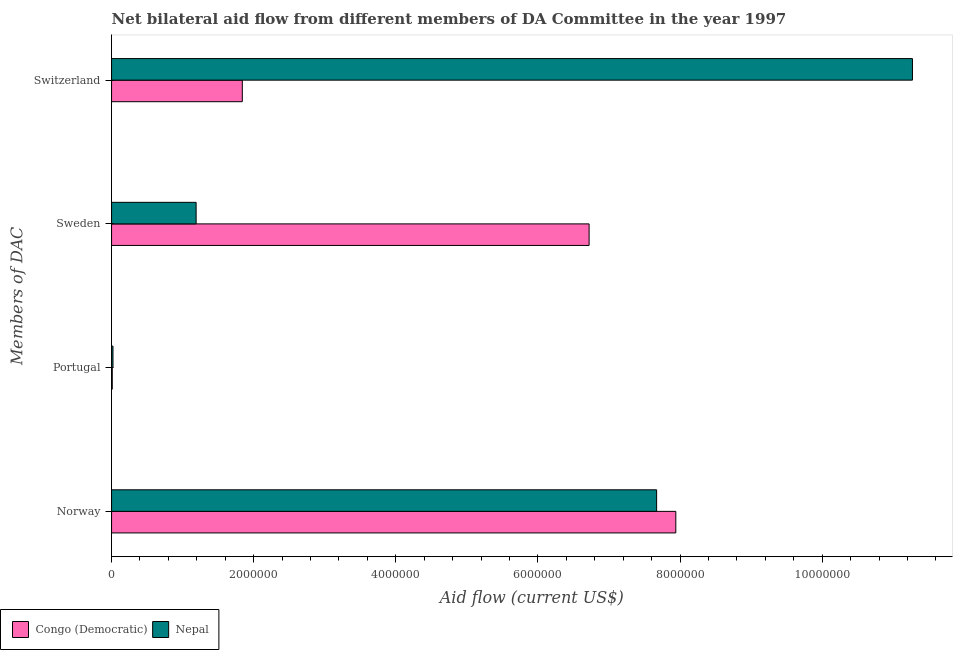How many different coloured bars are there?
Keep it short and to the point. 2. How many groups of bars are there?
Keep it short and to the point. 4. Are the number of bars per tick equal to the number of legend labels?
Offer a terse response. Yes. Are the number of bars on each tick of the Y-axis equal?
Offer a very short reply. Yes. How many bars are there on the 3rd tick from the top?
Provide a short and direct response. 2. How many bars are there on the 1st tick from the bottom?
Your answer should be compact. 2. What is the label of the 3rd group of bars from the top?
Provide a succinct answer. Portugal. What is the amount of aid given by switzerland in Nepal?
Keep it short and to the point. 1.13e+07. Across all countries, what is the maximum amount of aid given by switzerland?
Ensure brevity in your answer.  1.13e+07. Across all countries, what is the minimum amount of aid given by sweden?
Ensure brevity in your answer.  1.19e+06. In which country was the amount of aid given by portugal maximum?
Provide a short and direct response. Nepal. In which country was the amount of aid given by switzerland minimum?
Your response must be concise. Congo (Democratic). What is the total amount of aid given by switzerland in the graph?
Ensure brevity in your answer.  1.31e+07. What is the difference between the amount of aid given by sweden in Nepal and that in Congo (Democratic)?
Keep it short and to the point. -5.53e+06. What is the difference between the amount of aid given by sweden in Congo (Democratic) and the amount of aid given by portugal in Nepal?
Make the answer very short. 6.70e+06. What is the average amount of aid given by norway per country?
Ensure brevity in your answer.  7.80e+06. What is the difference between the amount of aid given by switzerland and amount of aid given by sweden in Congo (Democratic)?
Offer a very short reply. -4.88e+06. In how many countries, is the amount of aid given by sweden greater than 6800000 US$?
Your answer should be very brief. 0. What is the ratio of the amount of aid given by sweden in Congo (Democratic) to that in Nepal?
Your answer should be very brief. 5.65. Is the amount of aid given by sweden in Congo (Democratic) less than that in Nepal?
Make the answer very short. No. What is the difference between the highest and the second highest amount of aid given by sweden?
Ensure brevity in your answer.  5.53e+06. What is the difference between the highest and the lowest amount of aid given by norway?
Your response must be concise. 2.70e+05. In how many countries, is the amount of aid given by portugal greater than the average amount of aid given by portugal taken over all countries?
Your response must be concise. 1. Is the sum of the amount of aid given by sweden in Congo (Democratic) and Nepal greater than the maximum amount of aid given by norway across all countries?
Provide a succinct answer. No. Is it the case that in every country, the sum of the amount of aid given by portugal and amount of aid given by switzerland is greater than the sum of amount of aid given by sweden and amount of aid given by norway?
Your answer should be compact. No. What does the 1st bar from the top in Switzerland represents?
Your answer should be compact. Nepal. What does the 2nd bar from the bottom in Norway represents?
Provide a succinct answer. Nepal. How many bars are there?
Keep it short and to the point. 8. Are all the bars in the graph horizontal?
Offer a very short reply. Yes. How many countries are there in the graph?
Keep it short and to the point. 2. Does the graph contain grids?
Your answer should be compact. No. Where does the legend appear in the graph?
Your response must be concise. Bottom left. How many legend labels are there?
Provide a short and direct response. 2. How are the legend labels stacked?
Keep it short and to the point. Horizontal. What is the title of the graph?
Provide a succinct answer. Net bilateral aid flow from different members of DA Committee in the year 1997. What is the label or title of the Y-axis?
Your answer should be compact. Members of DAC. What is the Aid flow (current US$) in Congo (Democratic) in Norway?
Your answer should be compact. 7.94e+06. What is the Aid flow (current US$) in Nepal in Norway?
Your answer should be compact. 7.67e+06. What is the Aid flow (current US$) of Congo (Democratic) in Portugal?
Your answer should be compact. 10000. What is the Aid flow (current US$) of Congo (Democratic) in Sweden?
Your answer should be very brief. 6.72e+06. What is the Aid flow (current US$) of Nepal in Sweden?
Provide a short and direct response. 1.19e+06. What is the Aid flow (current US$) of Congo (Democratic) in Switzerland?
Give a very brief answer. 1.84e+06. What is the Aid flow (current US$) of Nepal in Switzerland?
Your response must be concise. 1.13e+07. Across all Members of DAC, what is the maximum Aid flow (current US$) of Congo (Democratic)?
Your answer should be very brief. 7.94e+06. Across all Members of DAC, what is the maximum Aid flow (current US$) of Nepal?
Provide a short and direct response. 1.13e+07. Across all Members of DAC, what is the minimum Aid flow (current US$) of Congo (Democratic)?
Ensure brevity in your answer.  10000. Across all Members of DAC, what is the minimum Aid flow (current US$) in Nepal?
Provide a short and direct response. 2.00e+04. What is the total Aid flow (current US$) in Congo (Democratic) in the graph?
Your response must be concise. 1.65e+07. What is the total Aid flow (current US$) in Nepal in the graph?
Keep it short and to the point. 2.02e+07. What is the difference between the Aid flow (current US$) in Congo (Democratic) in Norway and that in Portugal?
Your response must be concise. 7.93e+06. What is the difference between the Aid flow (current US$) in Nepal in Norway and that in Portugal?
Give a very brief answer. 7.65e+06. What is the difference between the Aid flow (current US$) in Congo (Democratic) in Norway and that in Sweden?
Your answer should be very brief. 1.22e+06. What is the difference between the Aid flow (current US$) of Nepal in Norway and that in Sweden?
Make the answer very short. 6.48e+06. What is the difference between the Aid flow (current US$) in Congo (Democratic) in Norway and that in Switzerland?
Offer a very short reply. 6.10e+06. What is the difference between the Aid flow (current US$) of Nepal in Norway and that in Switzerland?
Make the answer very short. -3.60e+06. What is the difference between the Aid flow (current US$) of Congo (Democratic) in Portugal and that in Sweden?
Make the answer very short. -6.71e+06. What is the difference between the Aid flow (current US$) in Nepal in Portugal and that in Sweden?
Keep it short and to the point. -1.17e+06. What is the difference between the Aid flow (current US$) in Congo (Democratic) in Portugal and that in Switzerland?
Ensure brevity in your answer.  -1.83e+06. What is the difference between the Aid flow (current US$) of Nepal in Portugal and that in Switzerland?
Ensure brevity in your answer.  -1.12e+07. What is the difference between the Aid flow (current US$) of Congo (Democratic) in Sweden and that in Switzerland?
Make the answer very short. 4.88e+06. What is the difference between the Aid flow (current US$) in Nepal in Sweden and that in Switzerland?
Your response must be concise. -1.01e+07. What is the difference between the Aid flow (current US$) of Congo (Democratic) in Norway and the Aid flow (current US$) of Nepal in Portugal?
Keep it short and to the point. 7.92e+06. What is the difference between the Aid flow (current US$) of Congo (Democratic) in Norway and the Aid flow (current US$) of Nepal in Sweden?
Give a very brief answer. 6.75e+06. What is the difference between the Aid flow (current US$) in Congo (Democratic) in Norway and the Aid flow (current US$) in Nepal in Switzerland?
Make the answer very short. -3.33e+06. What is the difference between the Aid flow (current US$) in Congo (Democratic) in Portugal and the Aid flow (current US$) in Nepal in Sweden?
Your response must be concise. -1.18e+06. What is the difference between the Aid flow (current US$) in Congo (Democratic) in Portugal and the Aid flow (current US$) in Nepal in Switzerland?
Offer a terse response. -1.13e+07. What is the difference between the Aid flow (current US$) in Congo (Democratic) in Sweden and the Aid flow (current US$) in Nepal in Switzerland?
Offer a terse response. -4.55e+06. What is the average Aid flow (current US$) of Congo (Democratic) per Members of DAC?
Offer a very short reply. 4.13e+06. What is the average Aid flow (current US$) of Nepal per Members of DAC?
Your answer should be very brief. 5.04e+06. What is the difference between the Aid flow (current US$) in Congo (Democratic) and Aid flow (current US$) in Nepal in Norway?
Provide a short and direct response. 2.70e+05. What is the difference between the Aid flow (current US$) of Congo (Democratic) and Aid flow (current US$) of Nepal in Sweden?
Your answer should be very brief. 5.53e+06. What is the difference between the Aid flow (current US$) of Congo (Democratic) and Aid flow (current US$) of Nepal in Switzerland?
Offer a very short reply. -9.43e+06. What is the ratio of the Aid flow (current US$) of Congo (Democratic) in Norway to that in Portugal?
Provide a short and direct response. 794. What is the ratio of the Aid flow (current US$) in Nepal in Norway to that in Portugal?
Provide a succinct answer. 383.5. What is the ratio of the Aid flow (current US$) in Congo (Democratic) in Norway to that in Sweden?
Make the answer very short. 1.18. What is the ratio of the Aid flow (current US$) in Nepal in Norway to that in Sweden?
Offer a very short reply. 6.45. What is the ratio of the Aid flow (current US$) of Congo (Democratic) in Norway to that in Switzerland?
Make the answer very short. 4.32. What is the ratio of the Aid flow (current US$) in Nepal in Norway to that in Switzerland?
Your response must be concise. 0.68. What is the ratio of the Aid flow (current US$) in Congo (Democratic) in Portugal to that in Sweden?
Your answer should be very brief. 0. What is the ratio of the Aid flow (current US$) of Nepal in Portugal to that in Sweden?
Give a very brief answer. 0.02. What is the ratio of the Aid flow (current US$) in Congo (Democratic) in Portugal to that in Switzerland?
Your response must be concise. 0.01. What is the ratio of the Aid flow (current US$) in Nepal in Portugal to that in Switzerland?
Make the answer very short. 0. What is the ratio of the Aid flow (current US$) in Congo (Democratic) in Sweden to that in Switzerland?
Provide a succinct answer. 3.65. What is the ratio of the Aid flow (current US$) in Nepal in Sweden to that in Switzerland?
Offer a very short reply. 0.11. What is the difference between the highest and the second highest Aid flow (current US$) of Congo (Democratic)?
Make the answer very short. 1.22e+06. What is the difference between the highest and the second highest Aid flow (current US$) in Nepal?
Provide a short and direct response. 3.60e+06. What is the difference between the highest and the lowest Aid flow (current US$) in Congo (Democratic)?
Offer a terse response. 7.93e+06. What is the difference between the highest and the lowest Aid flow (current US$) of Nepal?
Ensure brevity in your answer.  1.12e+07. 